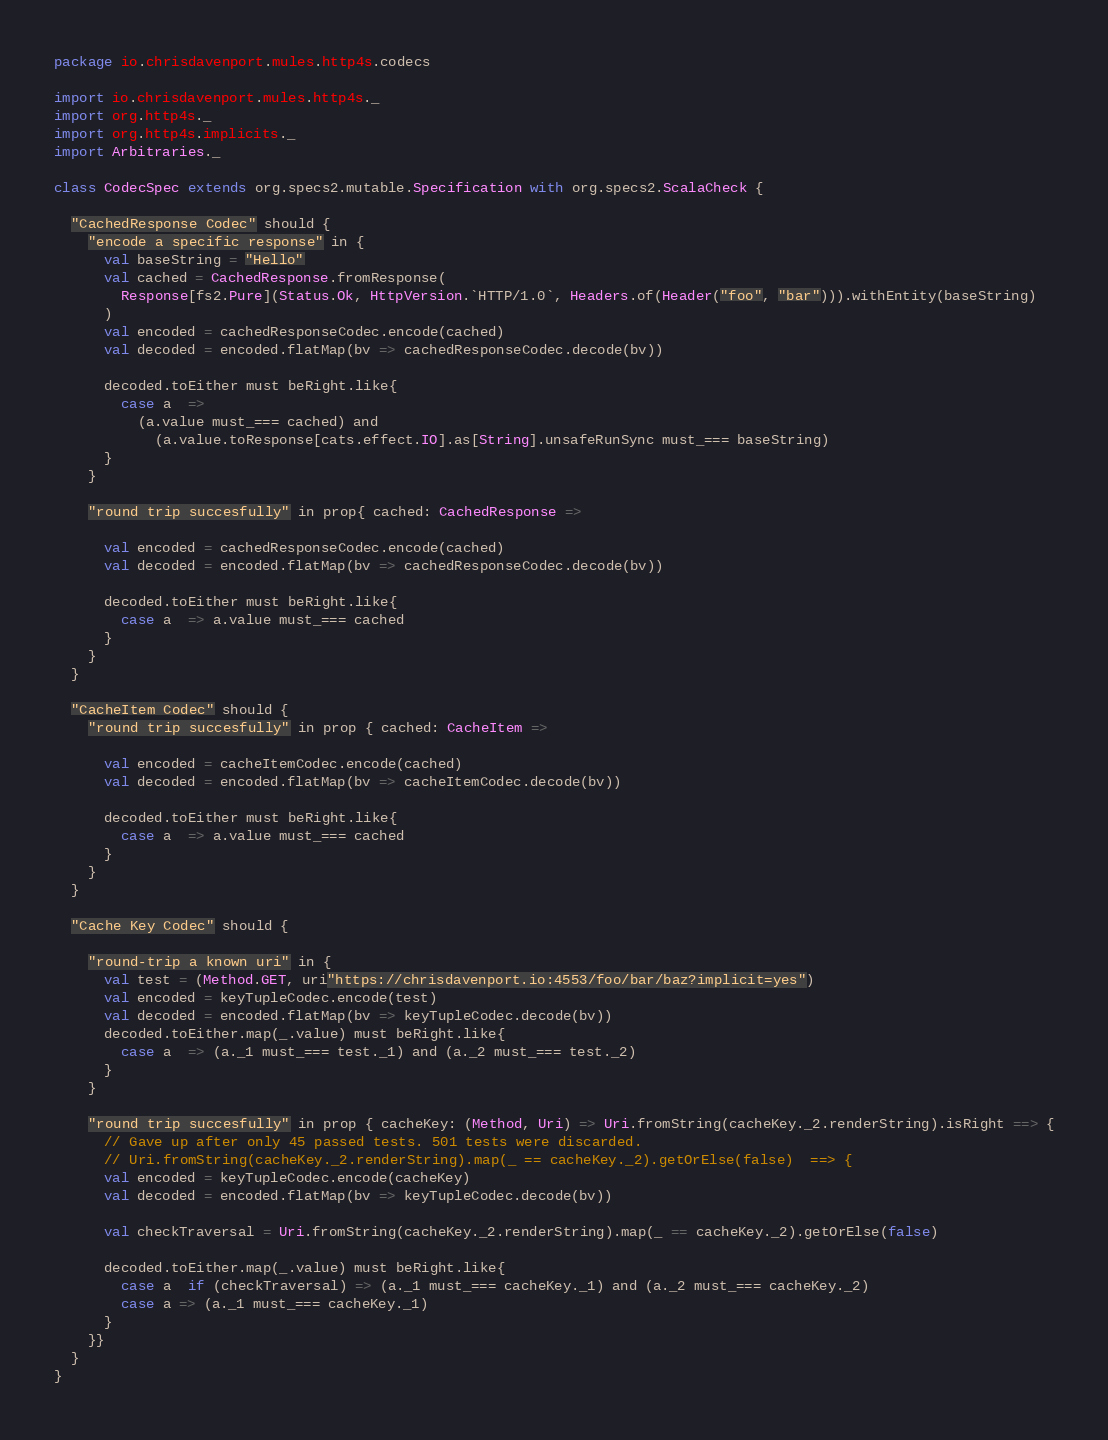Convert code to text. <code><loc_0><loc_0><loc_500><loc_500><_Scala_>package io.chrisdavenport.mules.http4s.codecs

import io.chrisdavenport.mules.http4s._
import org.http4s._
import org.http4s.implicits._
import Arbitraries._

class CodecSpec extends org.specs2.mutable.Specification with org.specs2.ScalaCheck {

  "CachedResponse Codec" should {
    "encode a specific response" in {
      val baseString = "Hello"
      val cached = CachedResponse.fromResponse(
        Response[fs2.Pure](Status.Ok, HttpVersion.`HTTP/1.0`, Headers.of(Header("foo", "bar"))).withEntity(baseString)
      )
      val encoded = cachedResponseCodec.encode(cached)
      val decoded = encoded.flatMap(bv => cachedResponseCodec.decode(bv))

      decoded.toEither must beRight.like{
        case a  => 
          (a.value must_=== cached) and
            (a.value.toResponse[cats.effect.IO].as[String].unsafeRunSync must_=== baseString)
      }
    }

    "round trip succesfully" in prop{ cached: CachedResponse =>

      val encoded = cachedResponseCodec.encode(cached)
      val decoded = encoded.flatMap(bv => cachedResponseCodec.decode(bv))

      decoded.toEither must beRight.like{
        case a  => a.value must_=== cached
      }
    }
  }

  "CacheItem Codec" should {
    "round trip succesfully" in prop { cached: CacheItem =>

      val encoded = cacheItemCodec.encode(cached)
      val decoded = encoded.flatMap(bv => cacheItemCodec.decode(bv))

      decoded.toEither must beRight.like{
        case a  => a.value must_=== cached
      }
    }
  }

  "Cache Key Codec" should {

    "round-trip a known uri" in {
      val test = (Method.GET, uri"https://chrisdavenport.io:4553/foo/bar/baz?implicit=yes")
      val encoded = keyTupleCodec.encode(test)
      val decoded = encoded.flatMap(bv => keyTupleCodec.decode(bv))
      decoded.toEither.map(_.value) must beRight.like{
        case a  => (a._1 must_=== test._1) and (a._2 must_=== test._2)
      }
    }

    "round trip succesfully" in prop { cacheKey: (Method, Uri) => Uri.fromString(cacheKey._2.renderString).isRight ==> {
      // Gave up after only 45 passed tests. 501 tests were discarded.
      // Uri.fromString(cacheKey._2.renderString).map(_ == cacheKey._2).getOrElse(false)  ==> {
      val encoded = keyTupleCodec.encode(cacheKey)
      val decoded = encoded.flatMap(bv => keyTupleCodec.decode(bv))

      val checkTraversal = Uri.fromString(cacheKey._2.renderString).map(_ == cacheKey._2).getOrElse(false)
      
      decoded.toEither.map(_.value) must beRight.like{
        case a  if (checkTraversal) => (a._1 must_=== cacheKey._1) and (a._2 must_=== cacheKey._2)
        case a => (a._1 must_=== cacheKey._1)
      }
    }}
  }
}</code> 